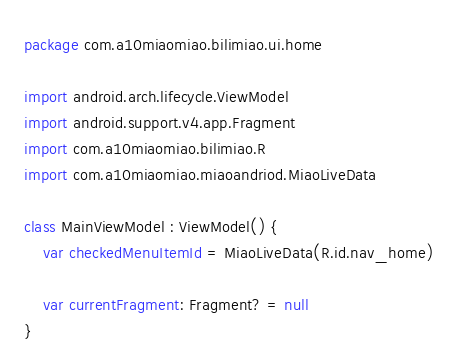<code> <loc_0><loc_0><loc_500><loc_500><_Kotlin_>package com.a10miaomiao.bilimiao.ui.home

import android.arch.lifecycle.ViewModel
import android.support.v4.app.Fragment
import com.a10miaomiao.bilimiao.R
import com.a10miaomiao.miaoandriod.MiaoLiveData

class MainViewModel : ViewModel() {
    var checkedMenuItemId = MiaoLiveData(R.id.nav_home)

    var currentFragment: Fragment? = null
}</code> 